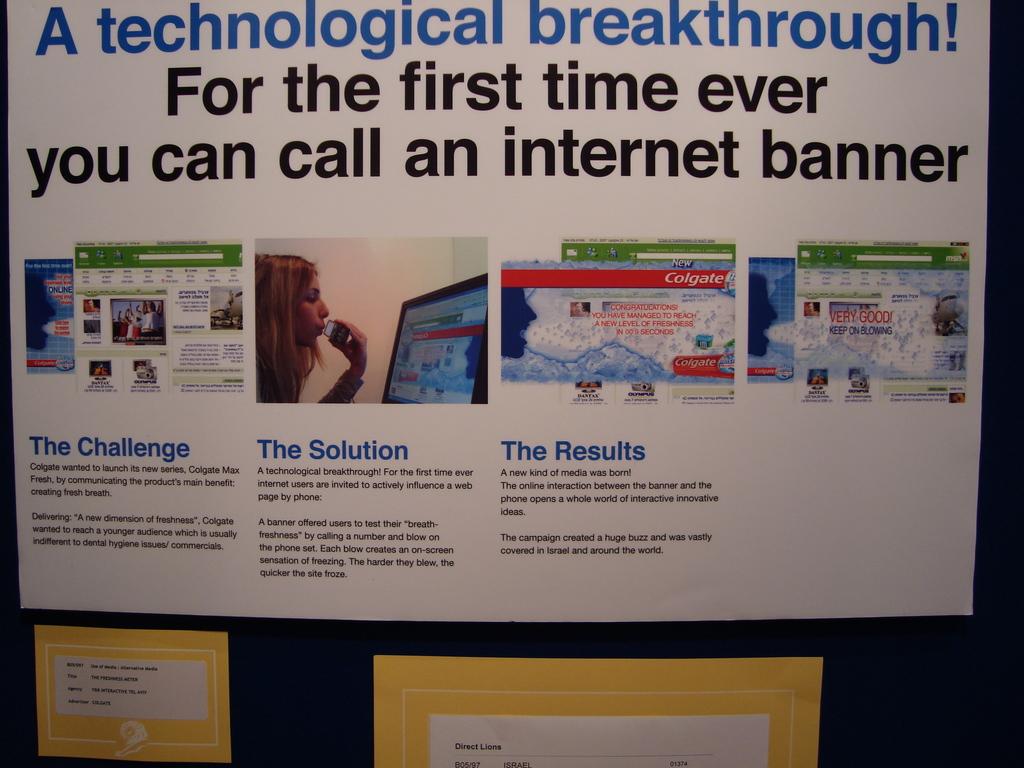What does it say above the pictures?
Offer a terse response. A technological breakthrough! for the first time ever you can call an internet banner. What does the poster say you can call for the first time?
Provide a short and direct response. Internet banner. 